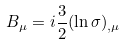Convert formula to latex. <formula><loc_0><loc_0><loc_500><loc_500>B _ { \mu } = i \frac { 3 } { 2 } ( \ln \sigma ) _ { , \mu }</formula> 